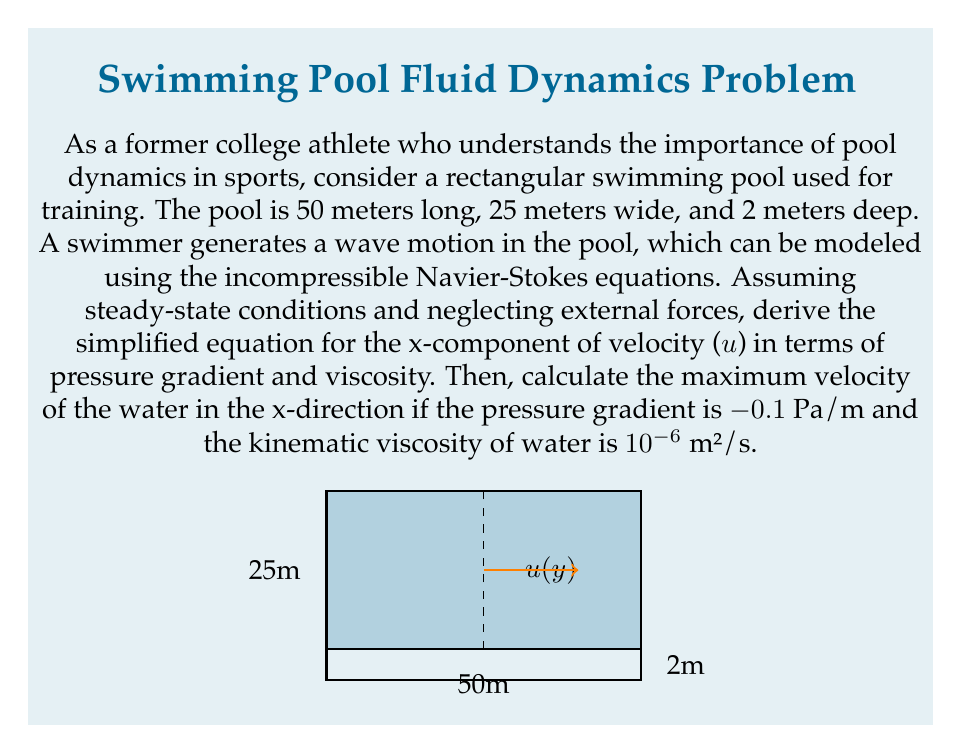Could you help me with this problem? Let's approach this step-by-step:

1) The incompressible Navier-Stokes equations in 3D are:

   $$\rho(\frac{\partial \mathbf{u}}{\partial t} + \mathbf{u} \cdot \nabla\mathbf{u}) = -\nabla p + \mu\nabla^2\mathbf{u} + \mathbf{F}$$

2) For steady-state conditions, $\frac{\partial \mathbf{u}}{\partial t} = 0$. We'll also neglect external forces $\mathbf{F}$.

3) For the x-component in a 2D flow (assuming no z-dependence), this becomes:

   $$\rho(u\frac{\partial u}{\partial x} + v\frac{\partial u}{\partial y}) = -\frac{\partial p}{\partial x} + \mu(\frac{\partial^2 u}{\partial x^2} + \frac{\partial^2 u}{\partial y^2})$$

4) For a fully developed flow, we can assume $\frac{\partial u}{\partial x} = 0$ and $v = 0$. This simplifies our equation to:

   $$0 = -\frac{\partial p}{\partial x} + \mu\frac{\partial^2 u}{\partial y^2}$$

5) Rearranging:

   $$\mu\frac{\partial^2 u}{\partial y^2} = \frac{\partial p}{\partial x}$$

6) The general solution to this equation is:

   $$u(y) = \frac{1}{2\mu}\frac{\partial p}{\partial x}y^2 + C_1y + C_2$$

7) Given the no-slip condition at the walls (y = 0 and y = 2m), we can determine that C₂ = 0 and C₁ = -2C₂.

8) Substituting these back, we get:

   $$u(y) = \frac{1}{2\mu}\frac{\partial p}{\partial x}y(2-y)$$

9) The maximum velocity occurs at y = 1m (middle of the pool). Substituting the given values:

   $$u_{max} = \frac{1}{2(10^{-6} \cdot 1000)}(-0.1)(1)(2-1) = 0.05 \text{ m/s}$$

   Note: We multiplied the kinematic viscosity by water density (1000 kg/m³) to get dynamic viscosity.
Answer: 0.05 m/s 